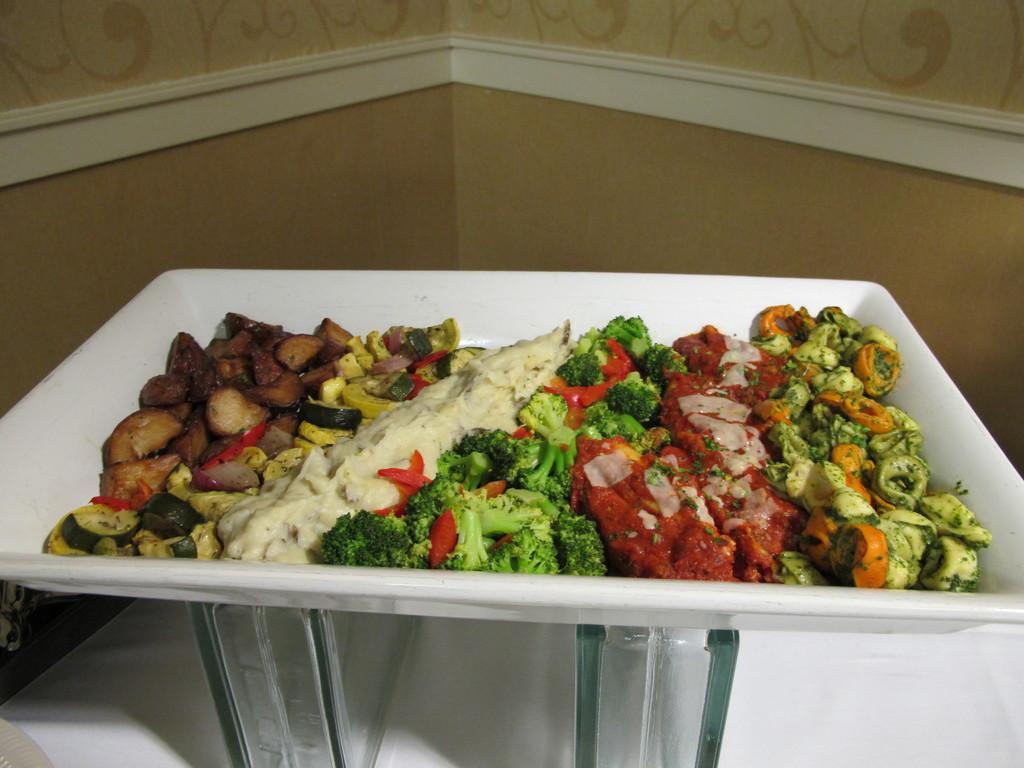In one or two sentences, can you explain what this image depicts? This image consists of a plate in which there is a food. The plate is white color is kept on the glass stands on the table. In the background, there is a wall in cream color. 